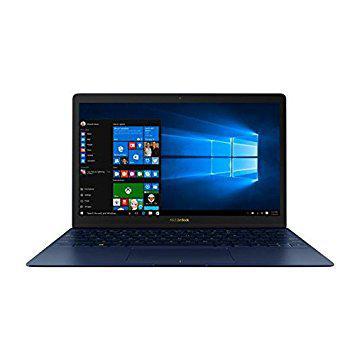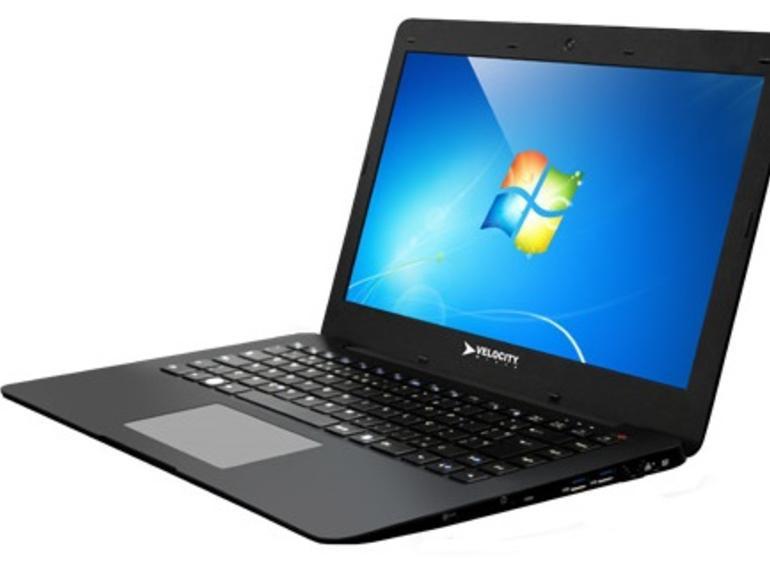The first image is the image on the left, the second image is the image on the right. Evaluate the accuracy of this statement regarding the images: "The screen on the left is displayed head-on, and the screen on the right is angled facing left.". Is it true? Answer yes or no. Yes. The first image is the image on the left, the second image is the image on the right. Examine the images to the left and right. Is the description "In at least one image there is one powered on laptop that top side is black and base is silver." accurate? Answer yes or no. No. 